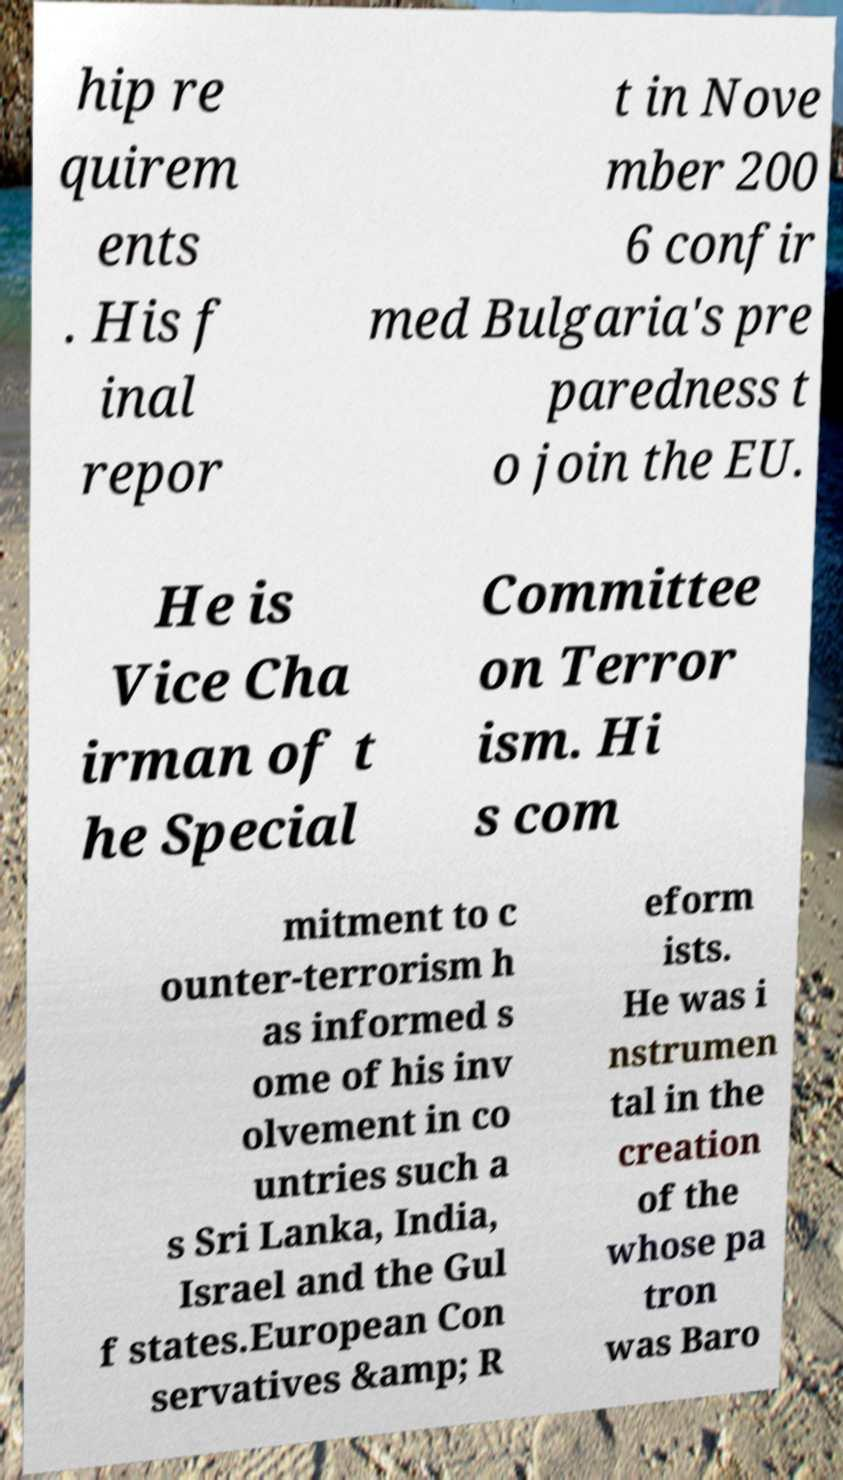What messages or text are displayed in this image? I need them in a readable, typed format. hip re quirem ents . His f inal repor t in Nove mber 200 6 confir med Bulgaria's pre paredness t o join the EU. He is Vice Cha irman of t he Special Committee on Terror ism. Hi s com mitment to c ounter-terrorism h as informed s ome of his inv olvement in co untries such a s Sri Lanka, India, Israel and the Gul f states.European Con servatives &amp; R eform ists. He was i nstrumen tal in the creation of the whose pa tron was Baro 